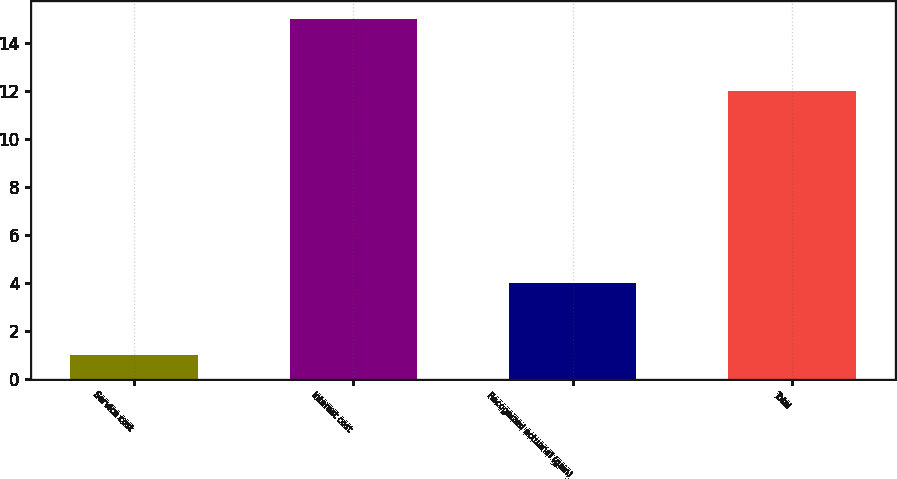<chart> <loc_0><loc_0><loc_500><loc_500><bar_chart><fcel>Service cost<fcel>Interest cost<fcel>Recognized actuarial (gain)<fcel>Total<nl><fcel>1<fcel>15<fcel>4<fcel>12<nl></chart> 